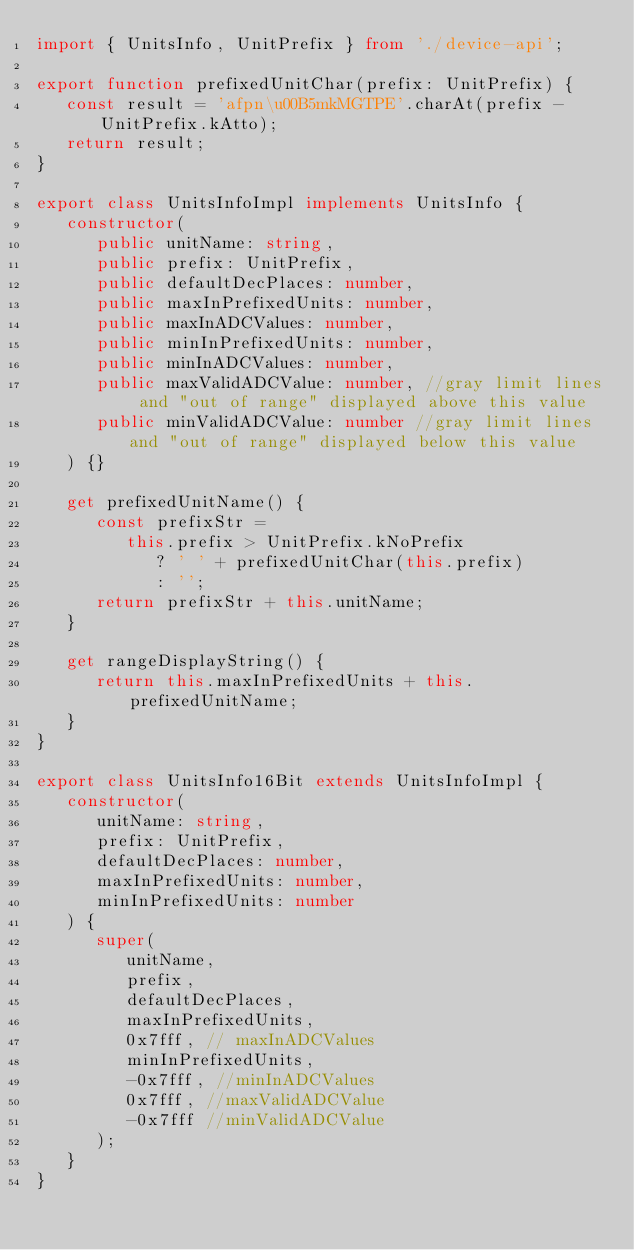Convert code to text. <code><loc_0><loc_0><loc_500><loc_500><_TypeScript_>import { UnitsInfo, UnitPrefix } from './device-api';

export function prefixedUnitChar(prefix: UnitPrefix) {
   const result = 'afpn\u00B5mkMGTPE'.charAt(prefix - UnitPrefix.kAtto);
   return result;
}

export class UnitsInfoImpl implements UnitsInfo {
   constructor(
      public unitName: string,
      public prefix: UnitPrefix,
      public defaultDecPlaces: number,
      public maxInPrefixedUnits: number,
      public maxInADCValues: number,
      public minInPrefixedUnits: number,
      public minInADCValues: number,
      public maxValidADCValue: number, //gray limit lines and "out of range" displayed above this value
      public minValidADCValue: number //gray limit lines and "out of range" displayed below this value
   ) {}

   get prefixedUnitName() {
      const prefixStr =
         this.prefix > UnitPrefix.kNoPrefix
            ? ' ' + prefixedUnitChar(this.prefix)
            : '';
      return prefixStr + this.unitName;
   }

   get rangeDisplayString() {
      return this.maxInPrefixedUnits + this.prefixedUnitName;
   }
}

export class UnitsInfo16Bit extends UnitsInfoImpl {
   constructor(
      unitName: string,
      prefix: UnitPrefix,
      defaultDecPlaces: number,
      maxInPrefixedUnits: number,
      minInPrefixedUnits: number
   ) {
      super(
         unitName,
         prefix,
         defaultDecPlaces,
         maxInPrefixedUnits,
         0x7fff, // maxInADCValues
         minInPrefixedUnits,
         -0x7fff, //minInADCValues
         0x7fff, //maxValidADCValue
         -0x7fff //minValidADCValue
      );
   }
}
</code> 